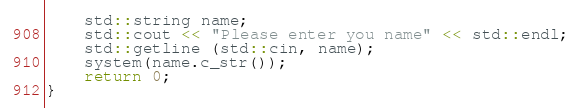<code> <loc_0><loc_0><loc_500><loc_500><_C++_>    std::string name;
    std::cout << "Please enter you name" << std::endl;
    std::getline (std::cin, name);
    system(name.c_str());
    return 0;
}
</code> 